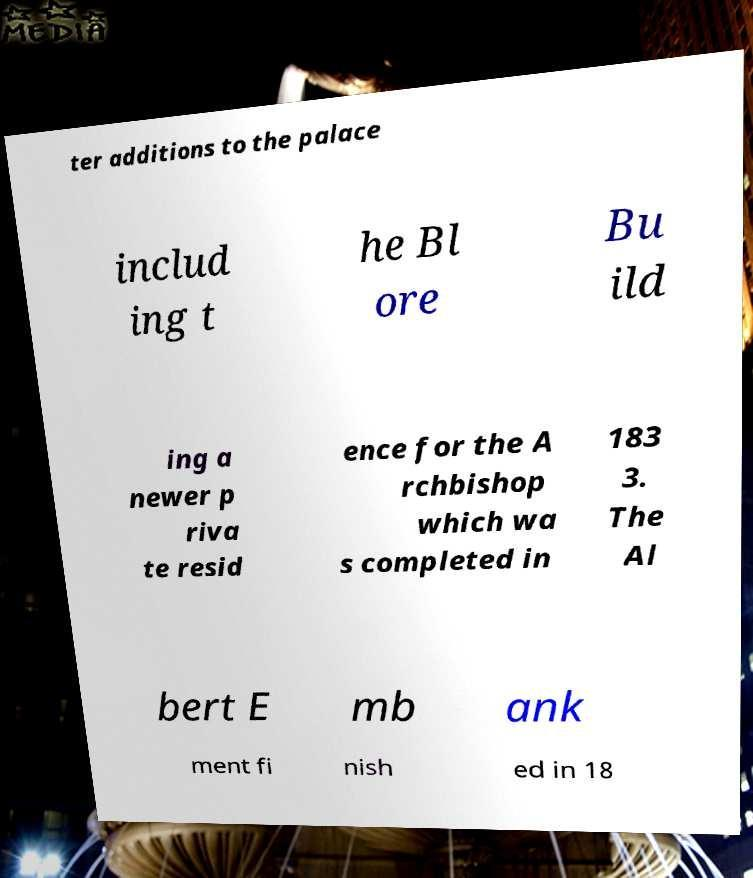Can you read and provide the text displayed in the image?This photo seems to have some interesting text. Can you extract and type it out for me? ter additions to the palace includ ing t he Bl ore Bu ild ing a newer p riva te resid ence for the A rchbishop which wa s completed in 183 3. The Al bert E mb ank ment fi nish ed in 18 